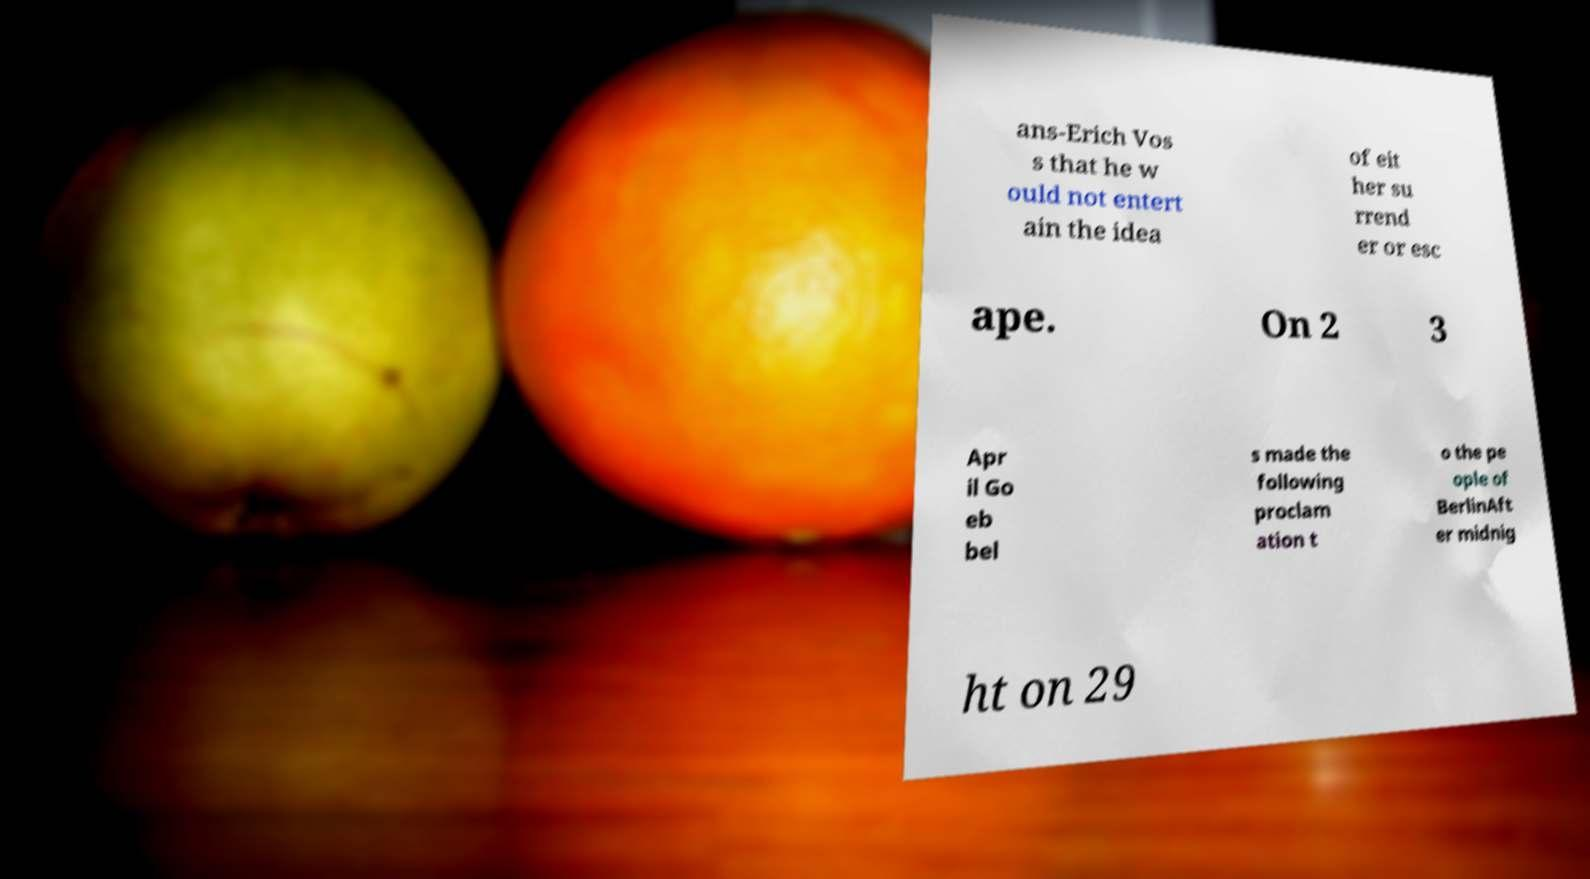Could you assist in decoding the text presented in this image and type it out clearly? ans-Erich Vos s that he w ould not entert ain the idea of eit her su rrend er or esc ape. On 2 3 Apr il Go eb bel s made the following proclam ation t o the pe ople of BerlinAft er midnig ht on 29 